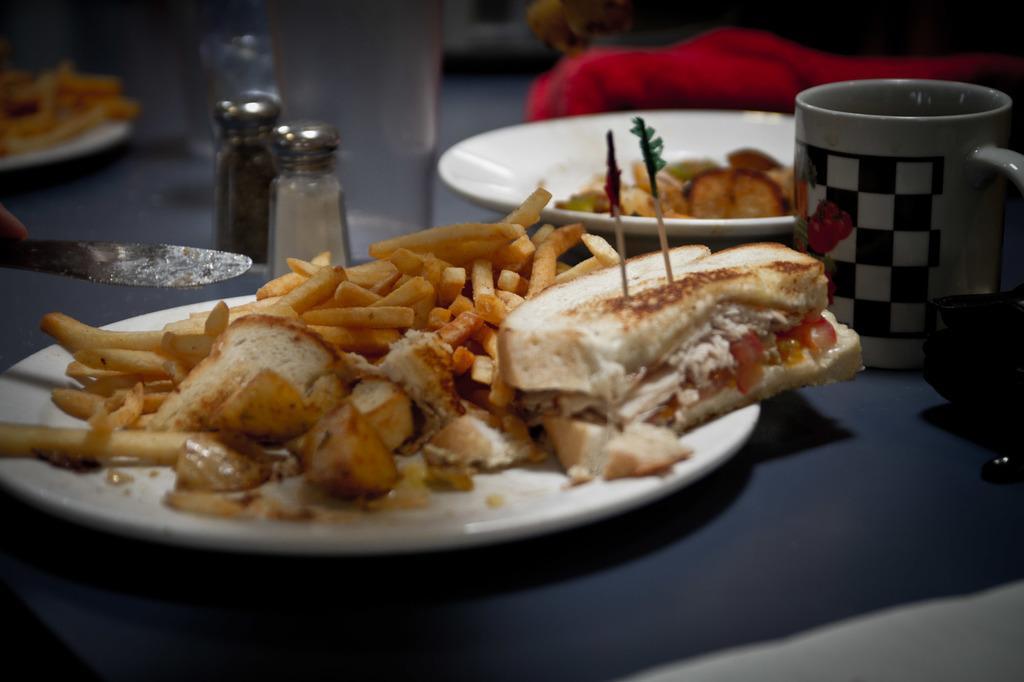Please provide a concise description of this image. In this picture we can see plates with food items on it, cup, jars, knife, glass and these all are placed on a platform. 